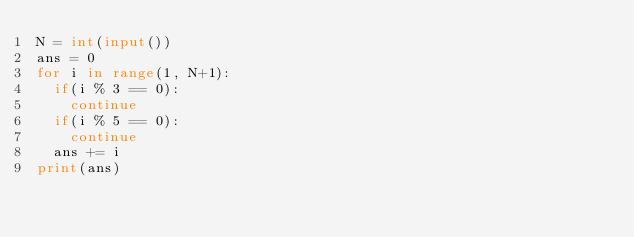Convert code to text. <code><loc_0><loc_0><loc_500><loc_500><_Python_>N = int(input())
ans = 0
for i in range(1, N+1):
  if(i % 3 == 0):
    continue
  if(i % 5 == 0):
    continue
  ans += i
print(ans)</code> 